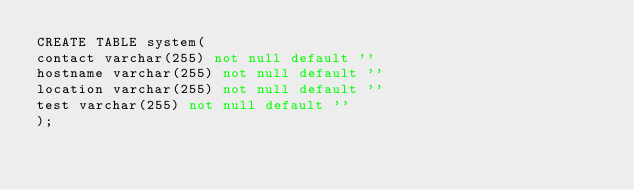<code> <loc_0><loc_0><loc_500><loc_500><_SQL_>CREATE TABLE system(
contact varchar(255) not null default ''
hostname varchar(255) not null default ''
location varchar(255) not null default ''
test varchar(255) not null default ''
);
</code> 